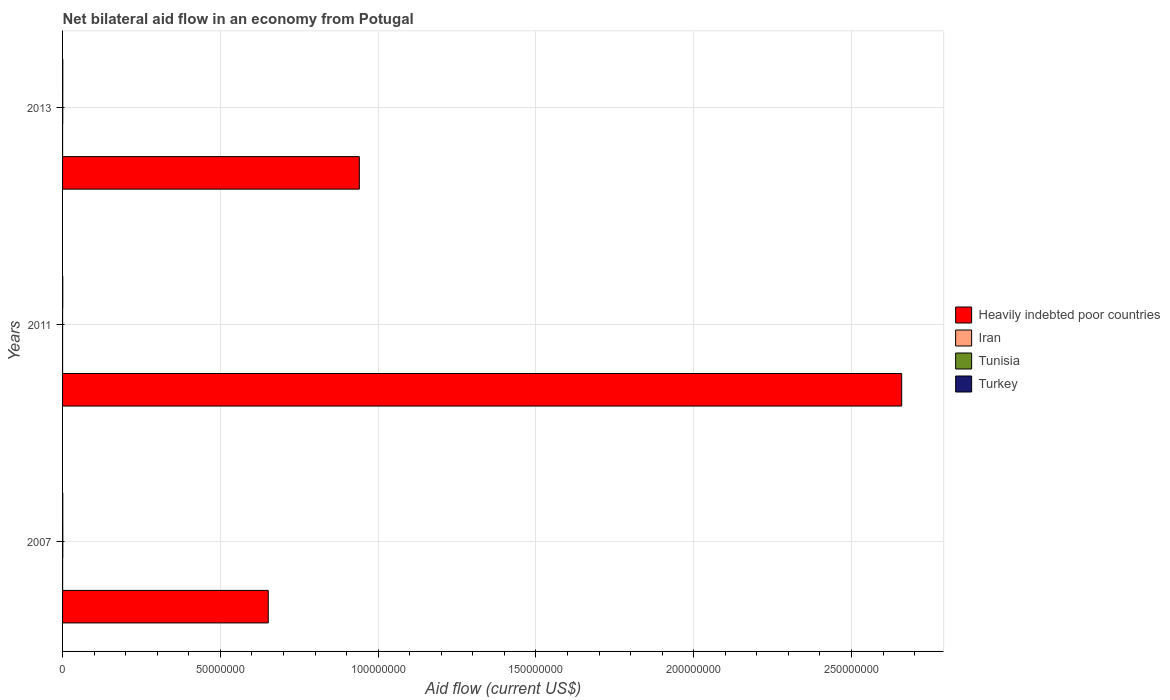How many different coloured bars are there?
Offer a very short reply. 4. Are the number of bars on each tick of the Y-axis equal?
Your response must be concise. Yes. How many bars are there on the 3rd tick from the bottom?
Your response must be concise. 4. In which year was the net bilateral aid flow in Heavily indebted poor countries maximum?
Ensure brevity in your answer.  2011. What is the total net bilateral aid flow in Heavily indebted poor countries in the graph?
Give a very brief answer. 4.25e+08. In the year 2007, what is the difference between the net bilateral aid flow in Heavily indebted poor countries and net bilateral aid flow in Iran?
Offer a terse response. 6.52e+07. What is the ratio of the net bilateral aid flow in Heavily indebted poor countries in 2007 to that in 2011?
Your response must be concise. 0.25. What is the difference between the highest and the second highest net bilateral aid flow in Tunisia?
Your response must be concise. 2.00e+04. What is the difference between the highest and the lowest net bilateral aid flow in Heavily indebted poor countries?
Offer a terse response. 2.01e+08. In how many years, is the net bilateral aid flow in Iran greater than the average net bilateral aid flow in Iran taken over all years?
Give a very brief answer. 1. What does the 3rd bar from the top in 2013 represents?
Your response must be concise. Iran. What does the 3rd bar from the bottom in 2011 represents?
Keep it short and to the point. Tunisia. Is it the case that in every year, the sum of the net bilateral aid flow in Heavily indebted poor countries and net bilateral aid flow in Iran is greater than the net bilateral aid flow in Tunisia?
Provide a short and direct response. Yes. How many bars are there?
Provide a succinct answer. 12. Are all the bars in the graph horizontal?
Your answer should be very brief. Yes. How many years are there in the graph?
Keep it short and to the point. 3. What is the difference between two consecutive major ticks on the X-axis?
Your answer should be compact. 5.00e+07. Are the values on the major ticks of X-axis written in scientific E-notation?
Offer a very short reply. No. What is the title of the graph?
Your answer should be very brief. Net bilateral aid flow in an economy from Potugal. What is the Aid flow (current US$) of Heavily indebted poor countries in 2007?
Keep it short and to the point. 6.52e+07. What is the Aid flow (current US$) of Tunisia in 2007?
Offer a very short reply. 8.00e+04. What is the Aid flow (current US$) of Turkey in 2007?
Make the answer very short. 7.00e+04. What is the Aid flow (current US$) in Heavily indebted poor countries in 2011?
Make the answer very short. 2.66e+08. What is the Aid flow (current US$) of Tunisia in 2011?
Your response must be concise. 10000. What is the Aid flow (current US$) in Heavily indebted poor countries in 2013?
Make the answer very short. 9.40e+07. What is the Aid flow (current US$) in Iran in 2013?
Your response must be concise. 10000. What is the Aid flow (current US$) of Tunisia in 2013?
Your response must be concise. 6.00e+04. Across all years, what is the maximum Aid flow (current US$) of Heavily indebted poor countries?
Keep it short and to the point. 2.66e+08. Across all years, what is the maximum Aid flow (current US$) of Turkey?
Ensure brevity in your answer.  7.00e+04. Across all years, what is the minimum Aid flow (current US$) in Heavily indebted poor countries?
Give a very brief answer. 6.52e+07. Across all years, what is the minimum Aid flow (current US$) of Iran?
Offer a terse response. 10000. What is the total Aid flow (current US$) in Heavily indebted poor countries in the graph?
Your answer should be compact. 4.25e+08. What is the total Aid flow (current US$) in Tunisia in the graph?
Give a very brief answer. 1.50e+05. What is the total Aid flow (current US$) of Turkey in the graph?
Offer a very short reply. 2.00e+05. What is the difference between the Aid flow (current US$) of Heavily indebted poor countries in 2007 and that in 2011?
Offer a terse response. -2.01e+08. What is the difference between the Aid flow (current US$) in Iran in 2007 and that in 2011?
Offer a terse response. 10000. What is the difference between the Aid flow (current US$) in Tunisia in 2007 and that in 2011?
Your answer should be very brief. 7.00e+04. What is the difference between the Aid flow (current US$) of Heavily indebted poor countries in 2007 and that in 2013?
Your answer should be compact. -2.89e+07. What is the difference between the Aid flow (current US$) in Heavily indebted poor countries in 2011 and that in 2013?
Your answer should be compact. 1.72e+08. What is the difference between the Aid flow (current US$) of Tunisia in 2011 and that in 2013?
Make the answer very short. -5.00e+04. What is the difference between the Aid flow (current US$) in Turkey in 2011 and that in 2013?
Keep it short and to the point. -10000. What is the difference between the Aid flow (current US$) in Heavily indebted poor countries in 2007 and the Aid flow (current US$) in Iran in 2011?
Provide a short and direct response. 6.52e+07. What is the difference between the Aid flow (current US$) of Heavily indebted poor countries in 2007 and the Aid flow (current US$) of Tunisia in 2011?
Your answer should be very brief. 6.52e+07. What is the difference between the Aid flow (current US$) in Heavily indebted poor countries in 2007 and the Aid flow (current US$) in Turkey in 2011?
Your answer should be compact. 6.51e+07. What is the difference between the Aid flow (current US$) of Iran in 2007 and the Aid flow (current US$) of Tunisia in 2011?
Provide a succinct answer. 10000. What is the difference between the Aid flow (current US$) of Iran in 2007 and the Aid flow (current US$) of Turkey in 2011?
Make the answer very short. -4.00e+04. What is the difference between the Aid flow (current US$) of Tunisia in 2007 and the Aid flow (current US$) of Turkey in 2011?
Offer a very short reply. 2.00e+04. What is the difference between the Aid flow (current US$) in Heavily indebted poor countries in 2007 and the Aid flow (current US$) in Iran in 2013?
Provide a short and direct response. 6.52e+07. What is the difference between the Aid flow (current US$) in Heavily indebted poor countries in 2007 and the Aid flow (current US$) in Tunisia in 2013?
Your answer should be compact. 6.51e+07. What is the difference between the Aid flow (current US$) of Heavily indebted poor countries in 2007 and the Aid flow (current US$) of Turkey in 2013?
Offer a very short reply. 6.51e+07. What is the difference between the Aid flow (current US$) of Iran in 2007 and the Aid flow (current US$) of Tunisia in 2013?
Your response must be concise. -4.00e+04. What is the difference between the Aid flow (current US$) in Iran in 2007 and the Aid flow (current US$) in Turkey in 2013?
Give a very brief answer. -5.00e+04. What is the difference between the Aid flow (current US$) in Heavily indebted poor countries in 2011 and the Aid flow (current US$) in Iran in 2013?
Provide a short and direct response. 2.66e+08. What is the difference between the Aid flow (current US$) in Heavily indebted poor countries in 2011 and the Aid flow (current US$) in Tunisia in 2013?
Make the answer very short. 2.66e+08. What is the difference between the Aid flow (current US$) in Heavily indebted poor countries in 2011 and the Aid flow (current US$) in Turkey in 2013?
Provide a succinct answer. 2.66e+08. What is the difference between the Aid flow (current US$) of Iran in 2011 and the Aid flow (current US$) of Turkey in 2013?
Provide a short and direct response. -6.00e+04. What is the difference between the Aid flow (current US$) in Tunisia in 2011 and the Aid flow (current US$) in Turkey in 2013?
Provide a succinct answer. -6.00e+04. What is the average Aid flow (current US$) of Heavily indebted poor countries per year?
Your answer should be compact. 1.42e+08. What is the average Aid flow (current US$) of Iran per year?
Ensure brevity in your answer.  1.33e+04. What is the average Aid flow (current US$) in Tunisia per year?
Your response must be concise. 5.00e+04. What is the average Aid flow (current US$) in Turkey per year?
Keep it short and to the point. 6.67e+04. In the year 2007, what is the difference between the Aid flow (current US$) in Heavily indebted poor countries and Aid flow (current US$) in Iran?
Your answer should be compact. 6.52e+07. In the year 2007, what is the difference between the Aid flow (current US$) of Heavily indebted poor countries and Aid flow (current US$) of Tunisia?
Keep it short and to the point. 6.51e+07. In the year 2007, what is the difference between the Aid flow (current US$) in Heavily indebted poor countries and Aid flow (current US$) in Turkey?
Keep it short and to the point. 6.51e+07. In the year 2007, what is the difference between the Aid flow (current US$) in Iran and Aid flow (current US$) in Tunisia?
Your answer should be very brief. -6.00e+04. In the year 2007, what is the difference between the Aid flow (current US$) in Iran and Aid flow (current US$) in Turkey?
Provide a short and direct response. -5.00e+04. In the year 2007, what is the difference between the Aid flow (current US$) in Tunisia and Aid flow (current US$) in Turkey?
Give a very brief answer. 10000. In the year 2011, what is the difference between the Aid flow (current US$) of Heavily indebted poor countries and Aid flow (current US$) of Iran?
Your answer should be compact. 2.66e+08. In the year 2011, what is the difference between the Aid flow (current US$) of Heavily indebted poor countries and Aid flow (current US$) of Tunisia?
Give a very brief answer. 2.66e+08. In the year 2011, what is the difference between the Aid flow (current US$) of Heavily indebted poor countries and Aid flow (current US$) of Turkey?
Your response must be concise. 2.66e+08. In the year 2011, what is the difference between the Aid flow (current US$) in Iran and Aid flow (current US$) in Tunisia?
Keep it short and to the point. 0. In the year 2013, what is the difference between the Aid flow (current US$) in Heavily indebted poor countries and Aid flow (current US$) in Iran?
Provide a succinct answer. 9.40e+07. In the year 2013, what is the difference between the Aid flow (current US$) in Heavily indebted poor countries and Aid flow (current US$) in Tunisia?
Ensure brevity in your answer.  9.40e+07. In the year 2013, what is the difference between the Aid flow (current US$) of Heavily indebted poor countries and Aid flow (current US$) of Turkey?
Offer a terse response. 9.40e+07. In the year 2013, what is the difference between the Aid flow (current US$) of Iran and Aid flow (current US$) of Tunisia?
Keep it short and to the point. -5.00e+04. What is the ratio of the Aid flow (current US$) in Heavily indebted poor countries in 2007 to that in 2011?
Your answer should be very brief. 0.25. What is the ratio of the Aid flow (current US$) in Iran in 2007 to that in 2011?
Provide a short and direct response. 2. What is the ratio of the Aid flow (current US$) in Tunisia in 2007 to that in 2011?
Provide a short and direct response. 8. What is the ratio of the Aid flow (current US$) of Turkey in 2007 to that in 2011?
Provide a succinct answer. 1.17. What is the ratio of the Aid flow (current US$) in Heavily indebted poor countries in 2007 to that in 2013?
Keep it short and to the point. 0.69. What is the ratio of the Aid flow (current US$) in Iran in 2007 to that in 2013?
Offer a very short reply. 2. What is the ratio of the Aid flow (current US$) of Heavily indebted poor countries in 2011 to that in 2013?
Your answer should be very brief. 2.83. What is the ratio of the Aid flow (current US$) in Tunisia in 2011 to that in 2013?
Offer a very short reply. 0.17. What is the difference between the highest and the second highest Aid flow (current US$) in Heavily indebted poor countries?
Your answer should be very brief. 1.72e+08. What is the difference between the highest and the second highest Aid flow (current US$) of Iran?
Your answer should be compact. 10000. What is the difference between the highest and the second highest Aid flow (current US$) in Tunisia?
Provide a succinct answer. 2.00e+04. What is the difference between the highest and the second highest Aid flow (current US$) of Turkey?
Give a very brief answer. 0. What is the difference between the highest and the lowest Aid flow (current US$) in Heavily indebted poor countries?
Your answer should be compact. 2.01e+08. What is the difference between the highest and the lowest Aid flow (current US$) in Iran?
Provide a succinct answer. 10000. What is the difference between the highest and the lowest Aid flow (current US$) in Tunisia?
Your response must be concise. 7.00e+04. 